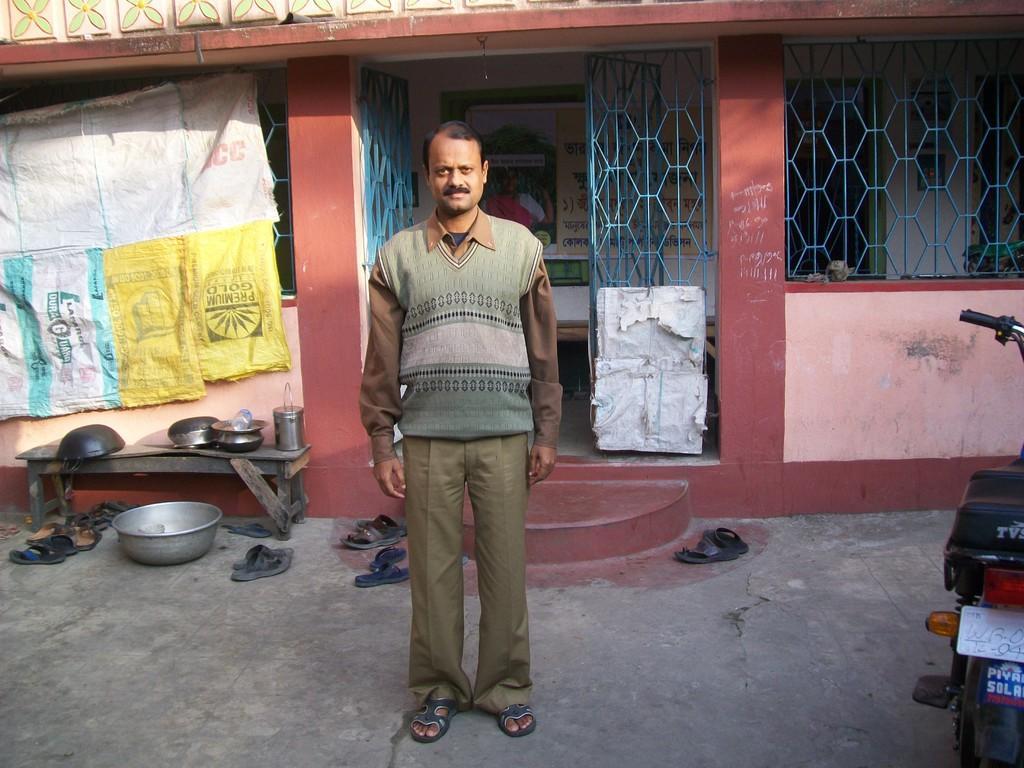Could you give a brief overview of what you see in this image? In this image there is a person standing, there is a vehicle truncated towards the right of the image, there are footwear on the ground, there is a vessel on the ground, there is a bench on the ground, there are vessels on the bench, there is a building truncated, there are objects truncated towards the left of the image, there is a gate, there is a wall, there is a banner on the wall, there is text on the banner, there is text on the wall. 